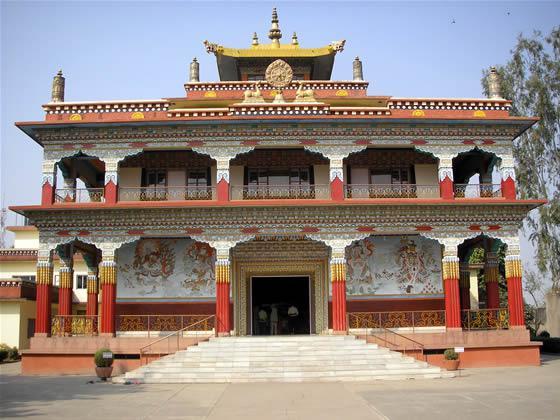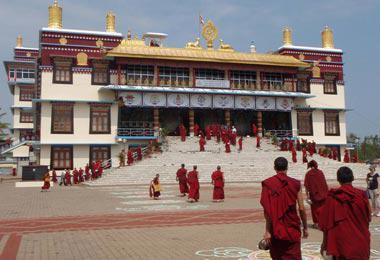The first image is the image on the left, the second image is the image on the right. Considering the images on both sides, is "An image shows a temple built in tiers that follow the shape of a side of a mountain." valid? Answer yes or no. No. The first image is the image on the left, the second image is the image on the right. For the images shown, is this caption "In one of images, there is a temple built on the side of a mountain." true? Answer yes or no. No. 